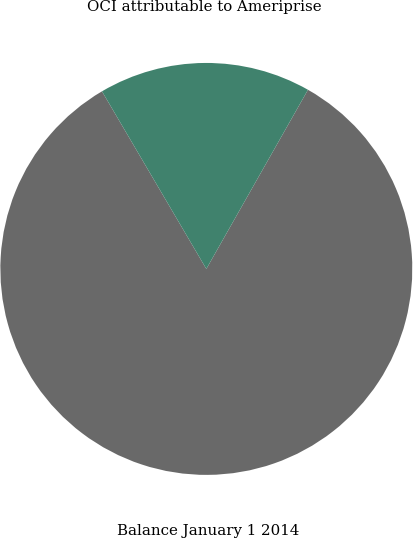<chart> <loc_0><loc_0><loc_500><loc_500><pie_chart><fcel>Balance January 1 2014<fcel>OCI attributable to Ameriprise<nl><fcel>83.33%<fcel>16.67%<nl></chart> 